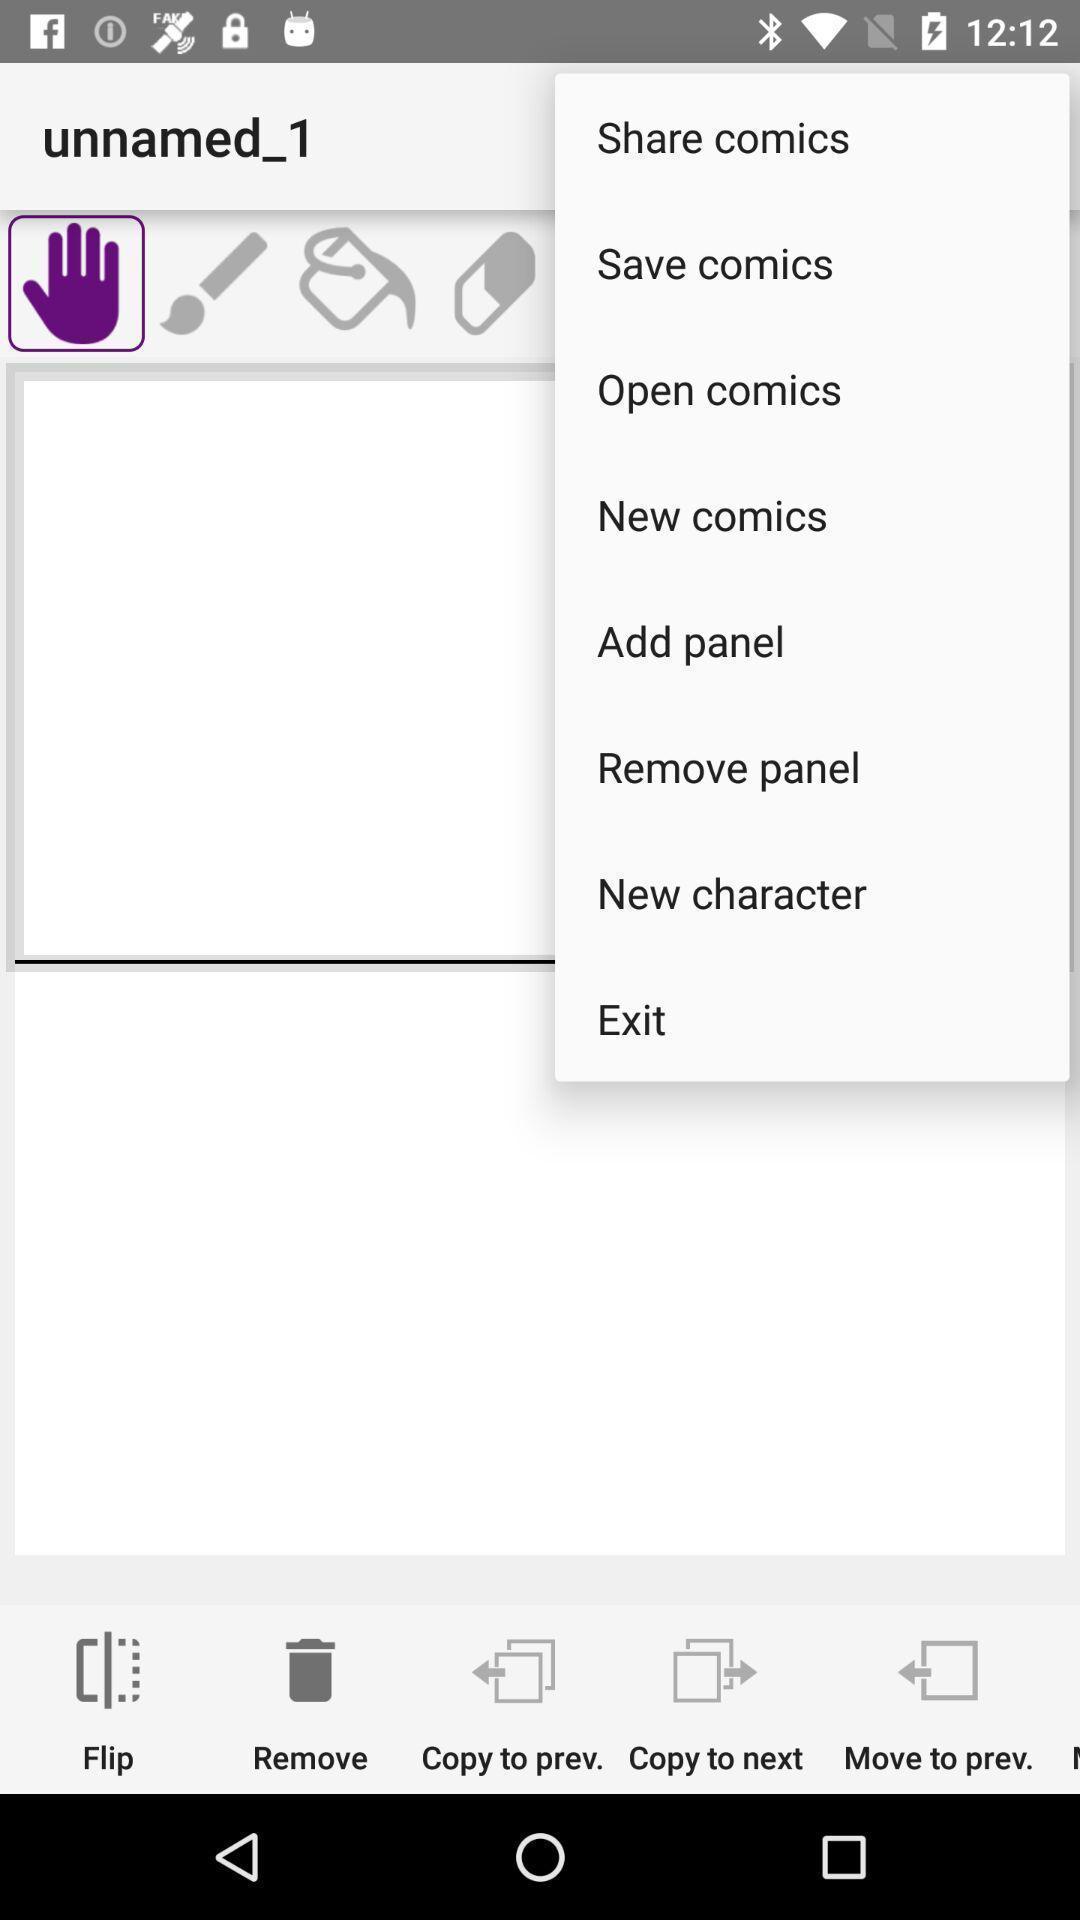Please provide a description for this image. Pop up page displaying various options. 